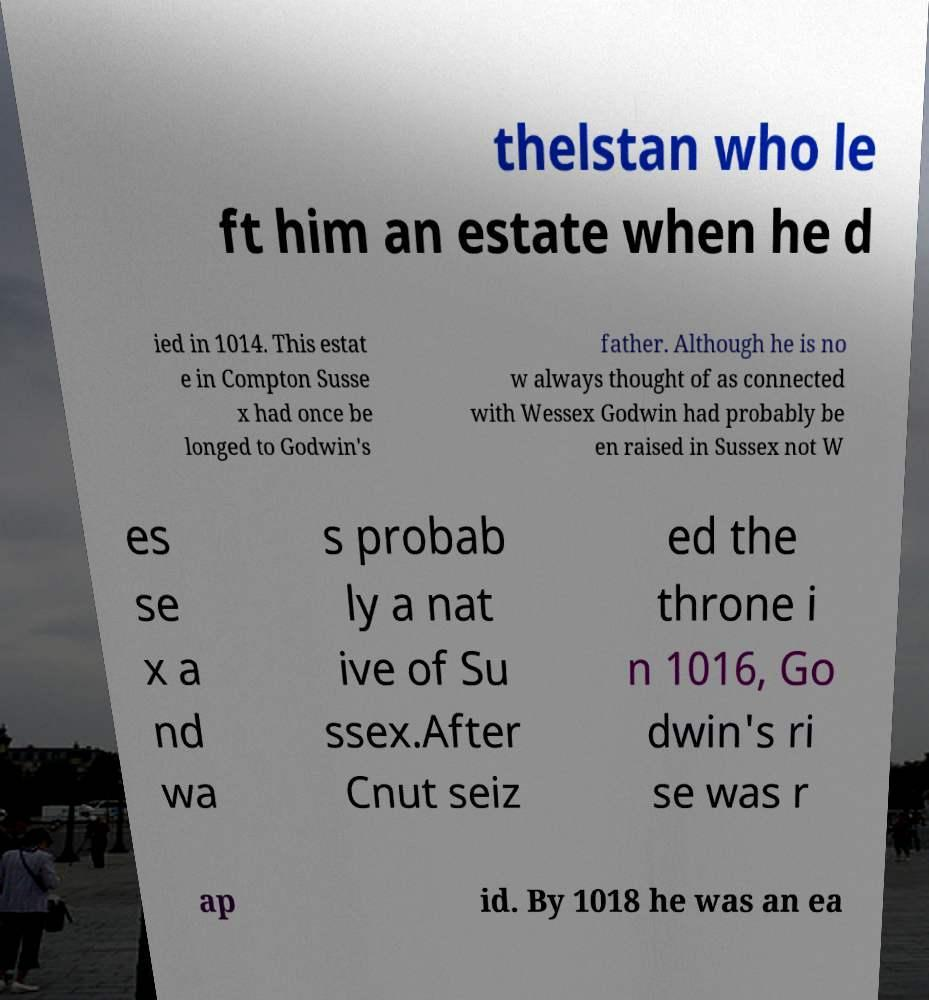What messages or text are displayed in this image? I need them in a readable, typed format. thelstan who le ft him an estate when he d ied in 1014. This estat e in Compton Susse x had once be longed to Godwin's father. Although he is no w always thought of as connected with Wessex Godwin had probably be en raised in Sussex not W es se x a nd wa s probab ly a nat ive of Su ssex.After Cnut seiz ed the throne i n 1016, Go dwin's ri se was r ap id. By 1018 he was an ea 